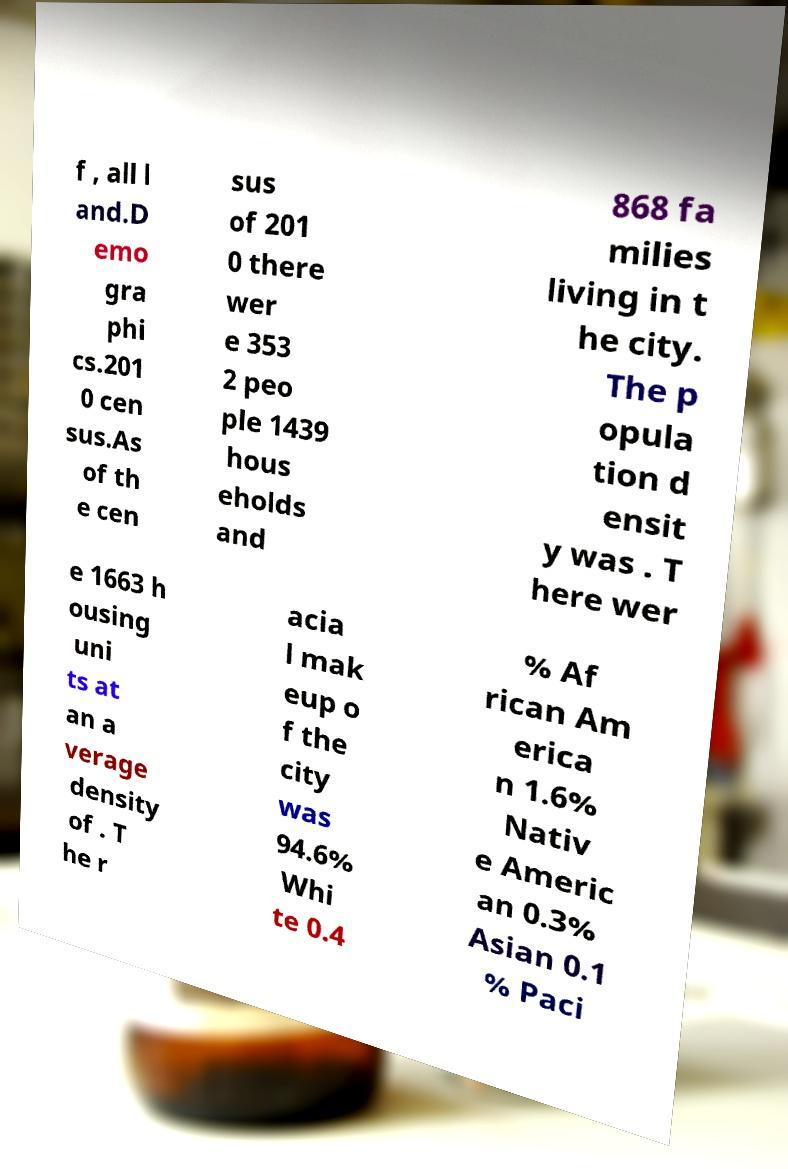Can you read and provide the text displayed in the image?This photo seems to have some interesting text. Can you extract and type it out for me? f , all l and.D emo gra phi cs.201 0 cen sus.As of th e cen sus of 201 0 there wer e 353 2 peo ple 1439 hous eholds and 868 fa milies living in t he city. The p opula tion d ensit y was . T here wer e 1663 h ousing uni ts at an a verage density of . T he r acia l mak eup o f the city was 94.6% Whi te 0.4 % Af rican Am erica n 1.6% Nativ e Americ an 0.3% Asian 0.1 % Paci 